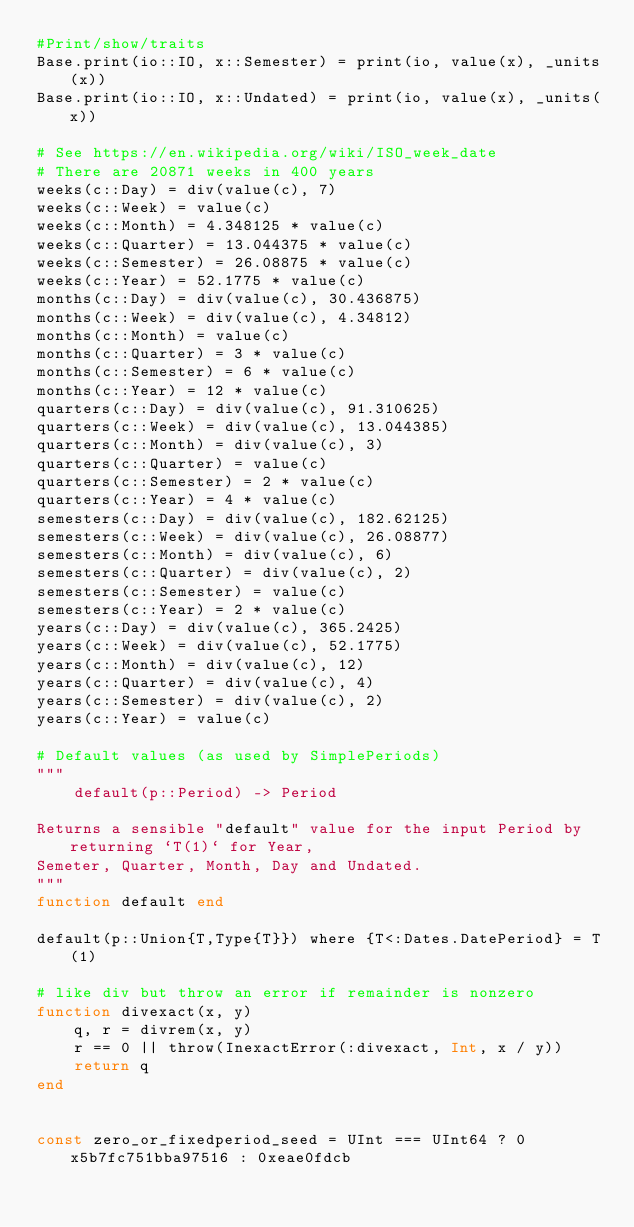Convert code to text. <code><loc_0><loc_0><loc_500><loc_500><_Julia_>#Print/show/traits
Base.print(io::IO, x::Semester) = print(io, value(x), _units(x))
Base.print(io::IO, x::Undated) = print(io, value(x), _units(x))

# See https://en.wikipedia.org/wiki/ISO_week_date
# There are 20871 weeks in 400 years
weeks(c::Day) = div(value(c), 7)
weeks(c::Week) = value(c)
weeks(c::Month) = 4.348125 * value(c)
weeks(c::Quarter) = 13.044375 * value(c)
weeks(c::Semester) = 26.08875 * value(c)
weeks(c::Year) = 52.1775 * value(c)
months(c::Day) = div(value(c), 30.436875)
months(c::Week) = div(value(c), 4.34812)
months(c::Month) = value(c)
months(c::Quarter) = 3 * value(c)
months(c::Semester) = 6 * value(c)
months(c::Year) = 12 * value(c)
quarters(c::Day) = div(value(c), 91.310625)
quarters(c::Week) = div(value(c), 13.044385)
quarters(c::Month) = div(value(c), 3)
quarters(c::Quarter) = value(c)
quarters(c::Semester) = 2 * value(c)
quarters(c::Year) = 4 * value(c)
semesters(c::Day) = div(value(c), 182.62125)
semesters(c::Week) = div(value(c), 26.08877)
semesters(c::Month) = div(value(c), 6)
semesters(c::Quarter) = div(value(c), 2)
semesters(c::Semester) = value(c)
semesters(c::Year) = 2 * value(c)
years(c::Day) = div(value(c), 365.2425)
years(c::Week) = div(value(c), 52.1775)
years(c::Month) = div(value(c), 12)
years(c::Quarter) = div(value(c), 4)
years(c::Semester) = div(value(c), 2)
years(c::Year) = value(c)

# Default values (as used by SimplePeriods)
"""
    default(p::Period) -> Period

Returns a sensible "default" value for the input Period by returning `T(1)` for Year,
Semeter, Quarter, Month, Day and Undated.
"""
function default end

default(p::Union{T,Type{T}}) where {T<:Dates.DatePeriod} = T(1)

# like div but throw an error if remainder is nonzero
function divexact(x, y)
    q, r = divrem(x, y)
    r == 0 || throw(InexactError(:divexact, Int, x / y))
    return q
end


const zero_or_fixedperiod_seed = UInt === UInt64 ? 0x5b7fc751bba97516 : 0xeae0fdcb</code> 